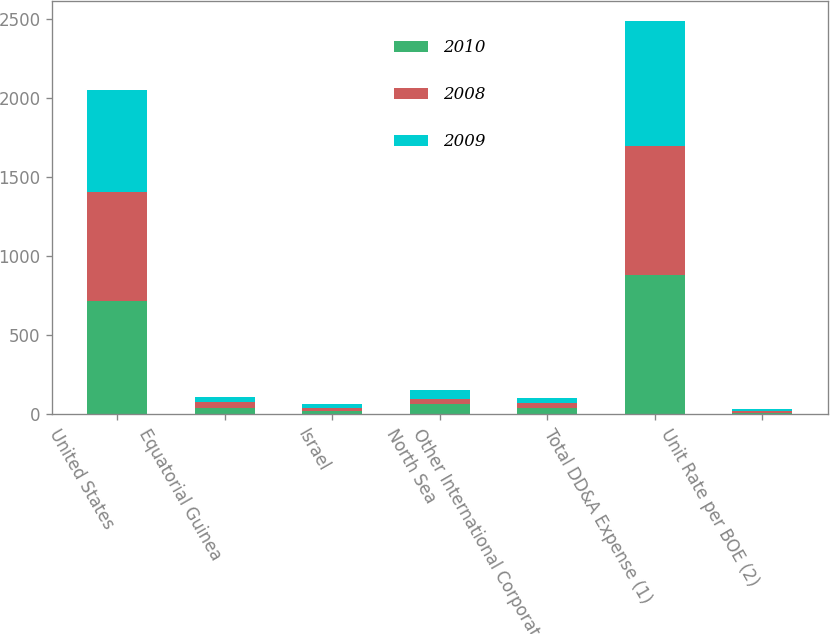Convert chart to OTSL. <chart><loc_0><loc_0><loc_500><loc_500><stacked_bar_chart><ecel><fcel>United States<fcel>Equatorial Guinea<fcel>Israel<fcel>North Sea<fcel>Other International Corporate<fcel>Total DD&A Expense (1)<fcel>Unit Rate per BOE (2)<nl><fcel>2010<fcel>719<fcel>39<fcel>22<fcel>64<fcel>39<fcel>883<fcel>11.57<nl><fcel>2008<fcel>689<fcel>38<fcel>20<fcel>34<fcel>35<fcel>816<fcel>11.08<nl><fcel>2009<fcel>646<fcel>34<fcel>24<fcel>55<fcel>32<fcel>791<fcel>10.44<nl></chart> 